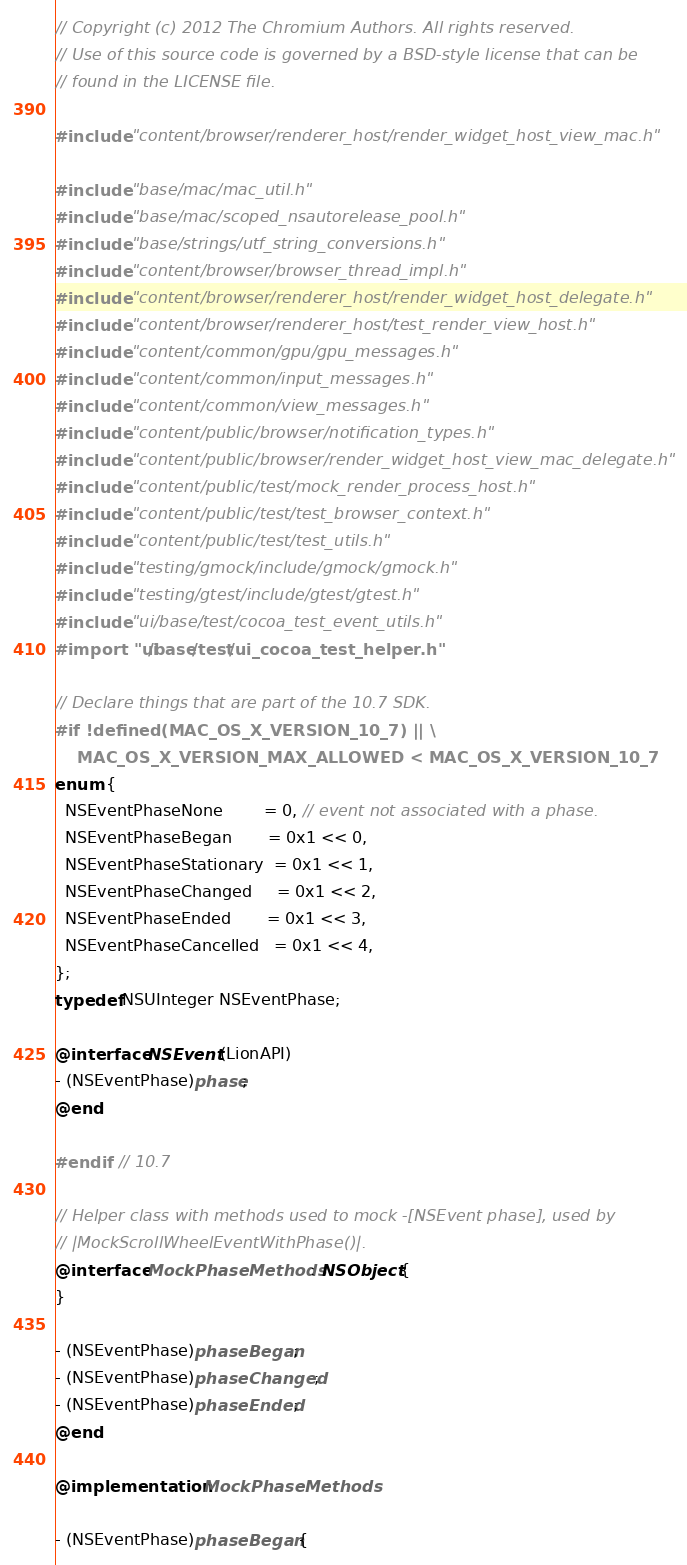<code> <loc_0><loc_0><loc_500><loc_500><_ObjectiveC_>// Copyright (c) 2012 The Chromium Authors. All rights reserved.
// Use of this source code is governed by a BSD-style license that can be
// found in the LICENSE file.

#include "content/browser/renderer_host/render_widget_host_view_mac.h"

#include "base/mac/mac_util.h"
#include "base/mac/scoped_nsautorelease_pool.h"
#include "base/strings/utf_string_conversions.h"
#include "content/browser/browser_thread_impl.h"
#include "content/browser/renderer_host/render_widget_host_delegate.h"
#include "content/browser/renderer_host/test_render_view_host.h"
#include "content/common/gpu/gpu_messages.h"
#include "content/common/input_messages.h"
#include "content/common/view_messages.h"
#include "content/public/browser/notification_types.h"
#include "content/public/browser/render_widget_host_view_mac_delegate.h"
#include "content/public/test/mock_render_process_host.h"
#include "content/public/test/test_browser_context.h"
#include "content/public/test/test_utils.h"
#include "testing/gmock/include/gmock/gmock.h"
#include "testing/gtest/include/gtest/gtest.h"
#include "ui/base/test/cocoa_test_event_utils.h"
#import "ui/base/test/ui_cocoa_test_helper.h"

// Declare things that are part of the 10.7 SDK.
#if !defined(MAC_OS_X_VERSION_10_7) || \
    MAC_OS_X_VERSION_MAX_ALLOWED < MAC_OS_X_VERSION_10_7
enum {
  NSEventPhaseNone        = 0, // event not associated with a phase.
  NSEventPhaseBegan       = 0x1 << 0,
  NSEventPhaseStationary  = 0x1 << 1,
  NSEventPhaseChanged     = 0x1 << 2,
  NSEventPhaseEnded       = 0x1 << 3,
  NSEventPhaseCancelled   = 0x1 << 4,
};
typedef NSUInteger NSEventPhase;

@interface NSEvent (LionAPI)
- (NSEventPhase)phase;
@end

#endif  // 10.7

// Helper class with methods used to mock -[NSEvent phase], used by
// |MockScrollWheelEventWithPhase()|.
@interface MockPhaseMethods : NSObject {
}

- (NSEventPhase)phaseBegan;
- (NSEventPhase)phaseChanged;
- (NSEventPhase)phaseEnded;
@end

@implementation MockPhaseMethods

- (NSEventPhase)phaseBegan {</code> 